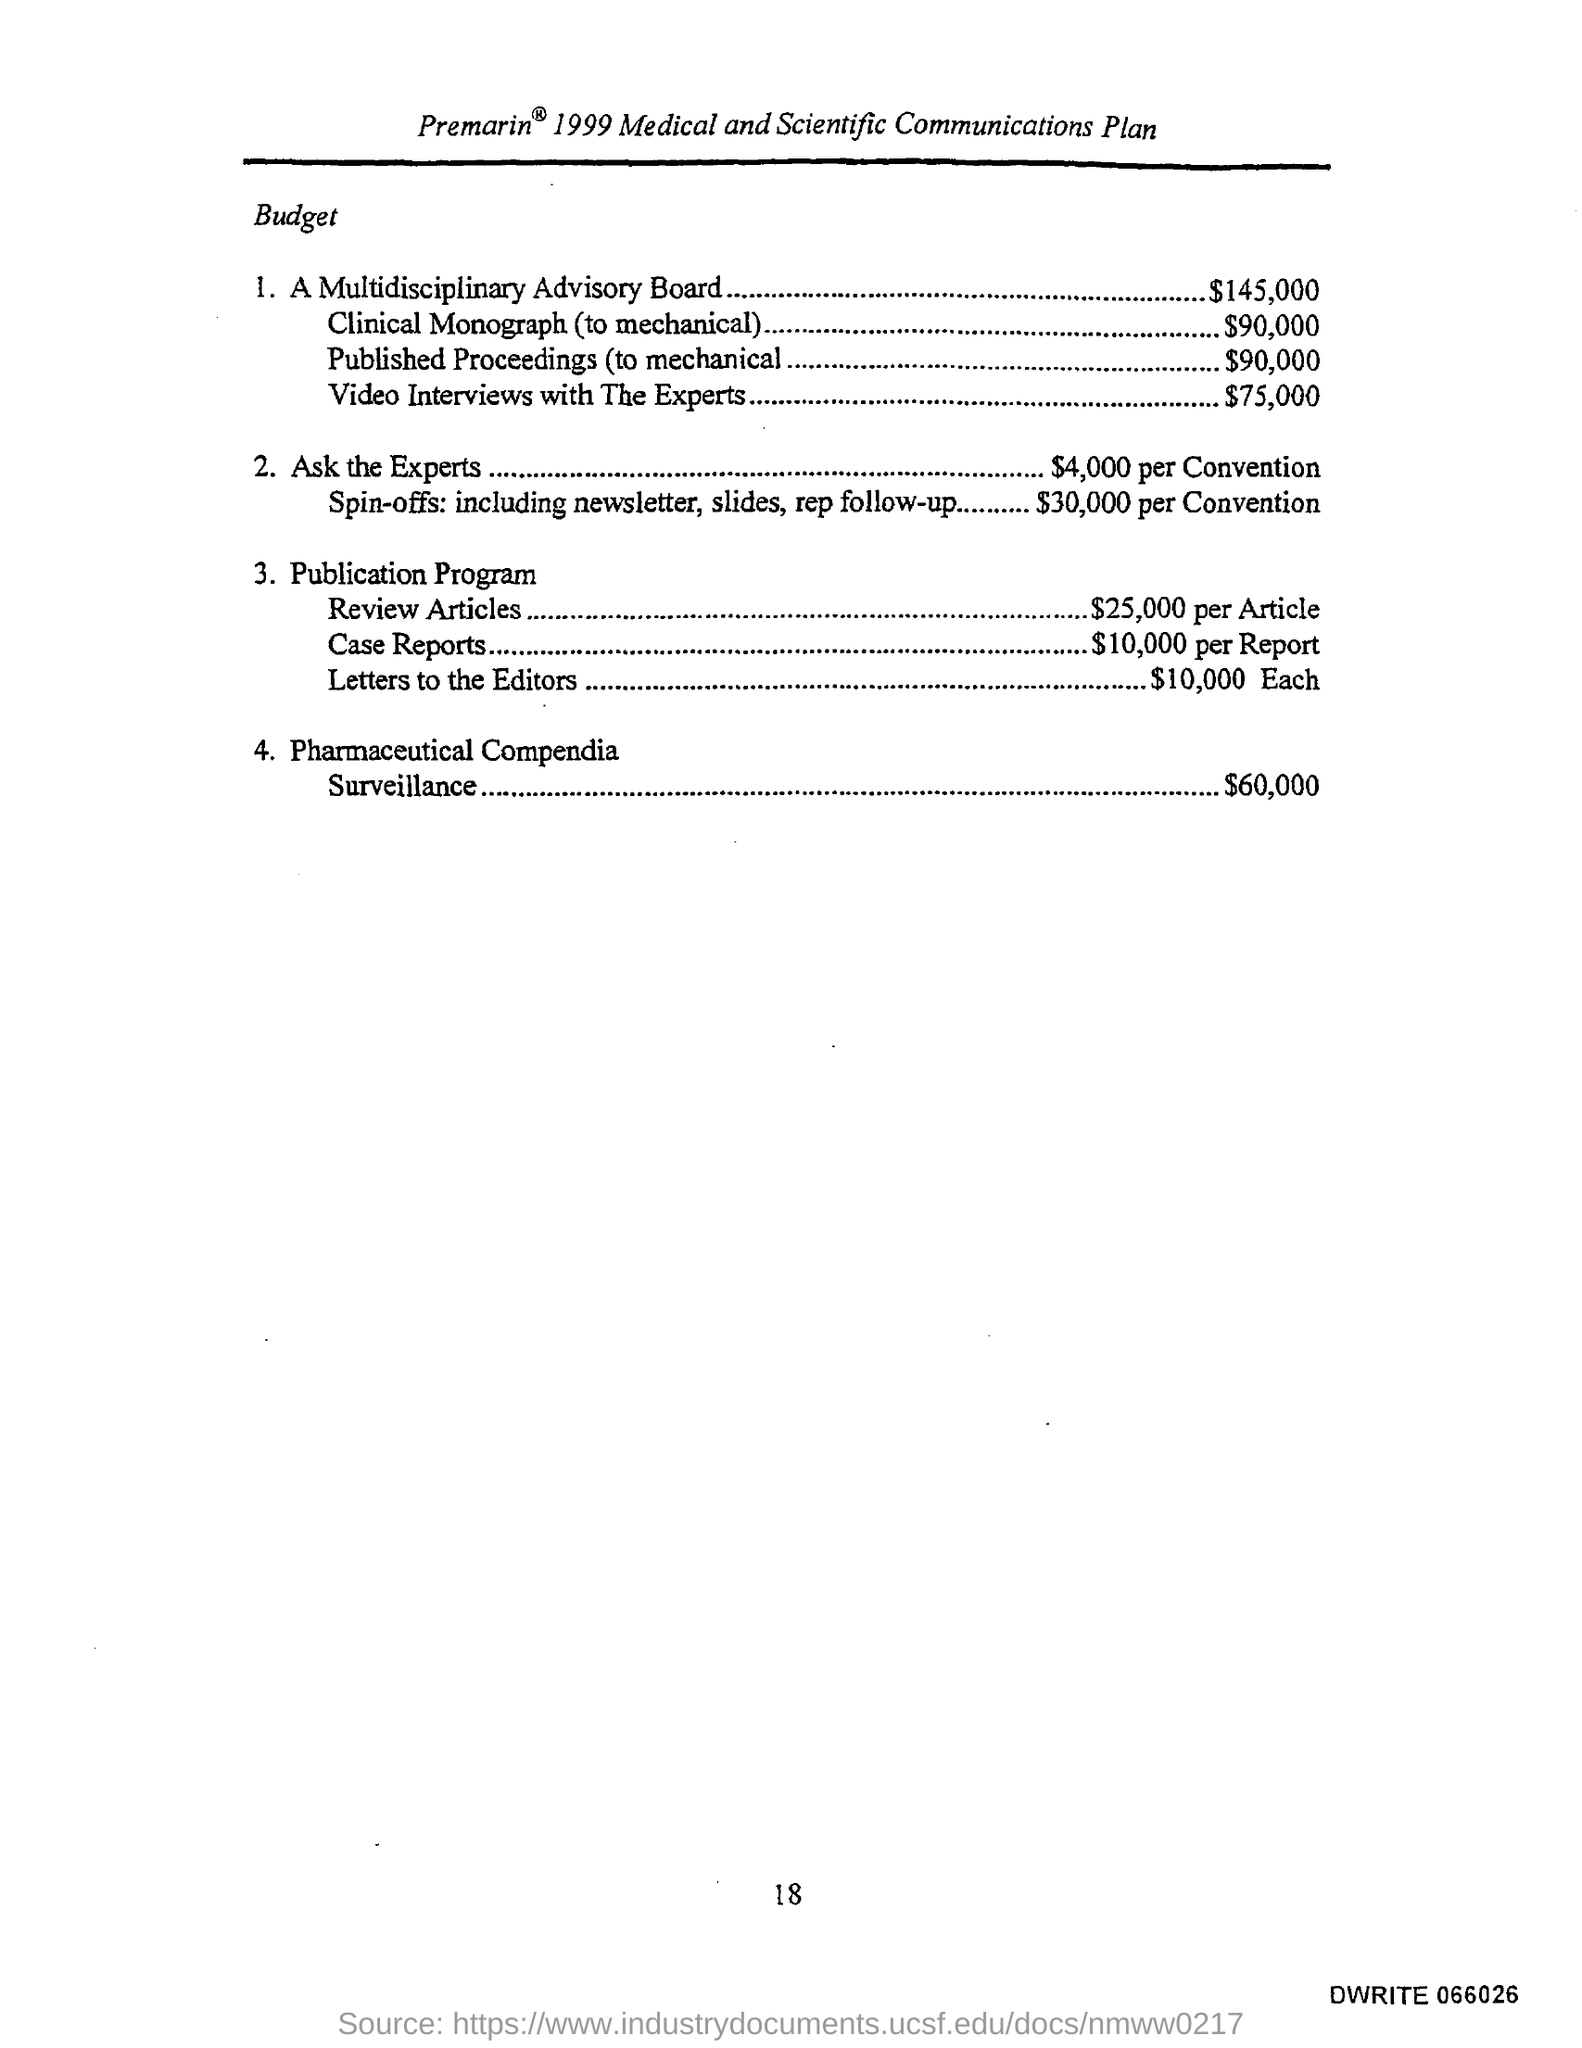What is the Budget for A Multidisciplinary Advisory Board?
Give a very brief answer. $145,000. What is the Budget for Clinical Monograph(to mechanical)?
Offer a terse response. $90,000. What is the Budget for Video Interviews with The Experts?
Provide a succinct answer. $75,000. What is the Budget for "Ask the Experts"?
Offer a very short reply. $4,000 per conversation. What is the Budget for publication Program "Review Articles"?
Ensure brevity in your answer.  $25,000 per article. What is the Budget for publication Program "Case Reports"?
Ensure brevity in your answer.  $10,000 per Report. What is the Budget for publication Program "Letters to Editors"?
Provide a short and direct response. $10,000 Each. What is the Budget for Pharmaceutical Compendia Surveillance?
Provide a succinct answer. $60,000. What is the Budget for Published Proceedings(to mechanical)?
Offer a very short reply. $90,000. 